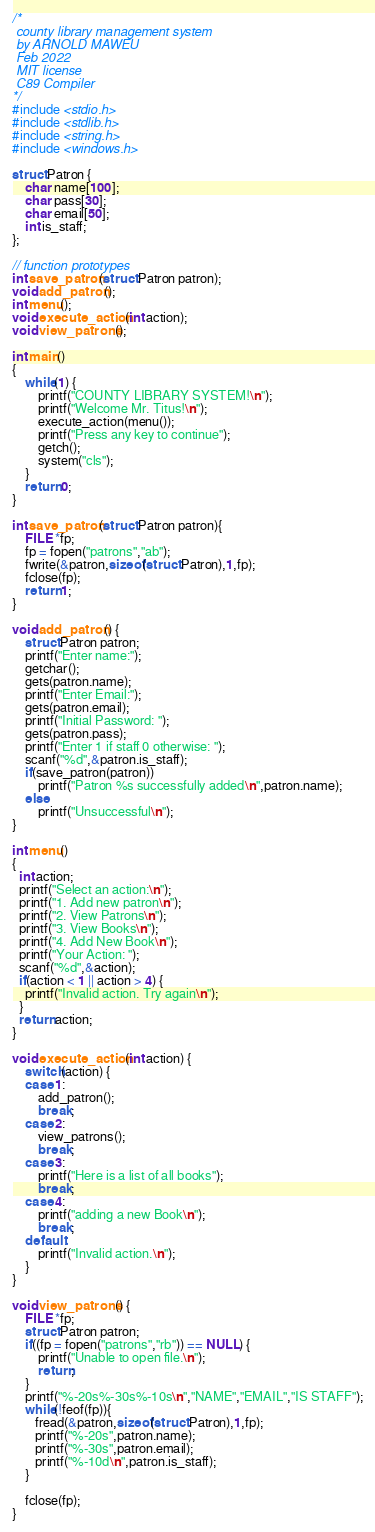<code> <loc_0><loc_0><loc_500><loc_500><_C_>/*
 county library management system
 by ARNOLD MAWEU
 Feb 2022
 MIT license
 C89 Compiler
*/
#include <stdio.h>
#include <stdlib.h>
#include <string.h>
#include <windows.h>

struct Patron {
    char name[100];
    char pass[30];
    char email[50];
    int is_staff;
};

// function prototypes
int save_patron(struct Patron patron);
void add_patron();
int menu();
void execute_action(int action);
void view_patrons();

int main()
{
    while(1) {
        printf("COUNTY LIBRARY SYSTEM!\n");
        printf("Welcome Mr. Titus!\n");
        execute_action(menu());
        printf("Press any key to continue");
        getch();
        system("cls");
    }
    return 0;
}

int save_patron(struct Patron patron){
    FILE *fp;
    fp = fopen("patrons","ab");
    fwrite(&patron,sizeof(struct Patron),1,fp);
    fclose(fp);
    return 1;
}

void add_patron() {
    struct Patron patron;
    printf("Enter name:");
    getchar();
    gets(patron.name);
    printf("Enter Email:");
    gets(patron.email);
    printf("Initial Password: ");
    gets(patron.pass);
    printf("Enter 1 if staff 0 otherwise: ");
    scanf("%d",&patron.is_staff);
    if(save_patron(patron))
        printf("Patron %s successfully added\n",patron.name);
    else
        printf("Unsuccessful\n");
}

int menu()
{
  int action;
  printf("Select an action:\n");
  printf("1. Add new patron\n");
  printf("2. View Patrons\n");
  printf("3. View Books\n");
  printf("4. Add New Book\n");
  printf("Your Action: ");
  scanf("%d",&action);
  if(action < 1 || action > 4) {
    printf("Invalid action. Try again\n");
  }
  return action;
}

void execute_action(int action) {
    switch(action) {
    case 1:
        add_patron();
        break;
    case 2:
        view_patrons();
        break;
    case 3:
        printf("Here is a list of all books");
        break;
    case 4:
        printf("adding a new Book\n");
        break;
    default:
        printf("Invalid action.\n");
    }
}

void view_patrons() {
    FILE *fp;
    struct Patron patron;
    if((fp = fopen("patrons","rb")) == NULL) {
        printf("Unable to open file.\n");
        return;
    }
    printf("%-20s%-30s%-10s\n","NAME","EMAIL","IS STAFF");
    while(!feof(fp)){
       fread(&patron,sizeof(struct Patron),1,fp);
       printf("%-20s",patron.name);
       printf("%-30s",patron.email);
       printf("%-10d\n",patron.is_staff);
    }

    fclose(fp);
}


</code> 